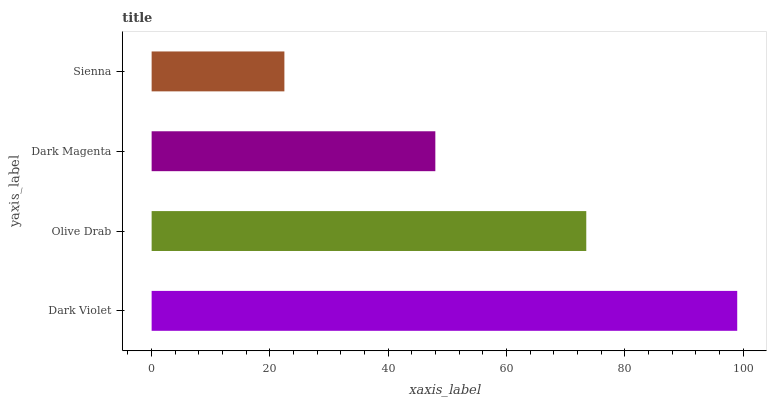Is Sienna the minimum?
Answer yes or no. Yes. Is Dark Violet the maximum?
Answer yes or no. Yes. Is Olive Drab the minimum?
Answer yes or no. No. Is Olive Drab the maximum?
Answer yes or no. No. Is Dark Violet greater than Olive Drab?
Answer yes or no. Yes. Is Olive Drab less than Dark Violet?
Answer yes or no. Yes. Is Olive Drab greater than Dark Violet?
Answer yes or no. No. Is Dark Violet less than Olive Drab?
Answer yes or no. No. Is Olive Drab the high median?
Answer yes or no. Yes. Is Dark Magenta the low median?
Answer yes or no. Yes. Is Sienna the high median?
Answer yes or no. No. Is Sienna the low median?
Answer yes or no. No. 